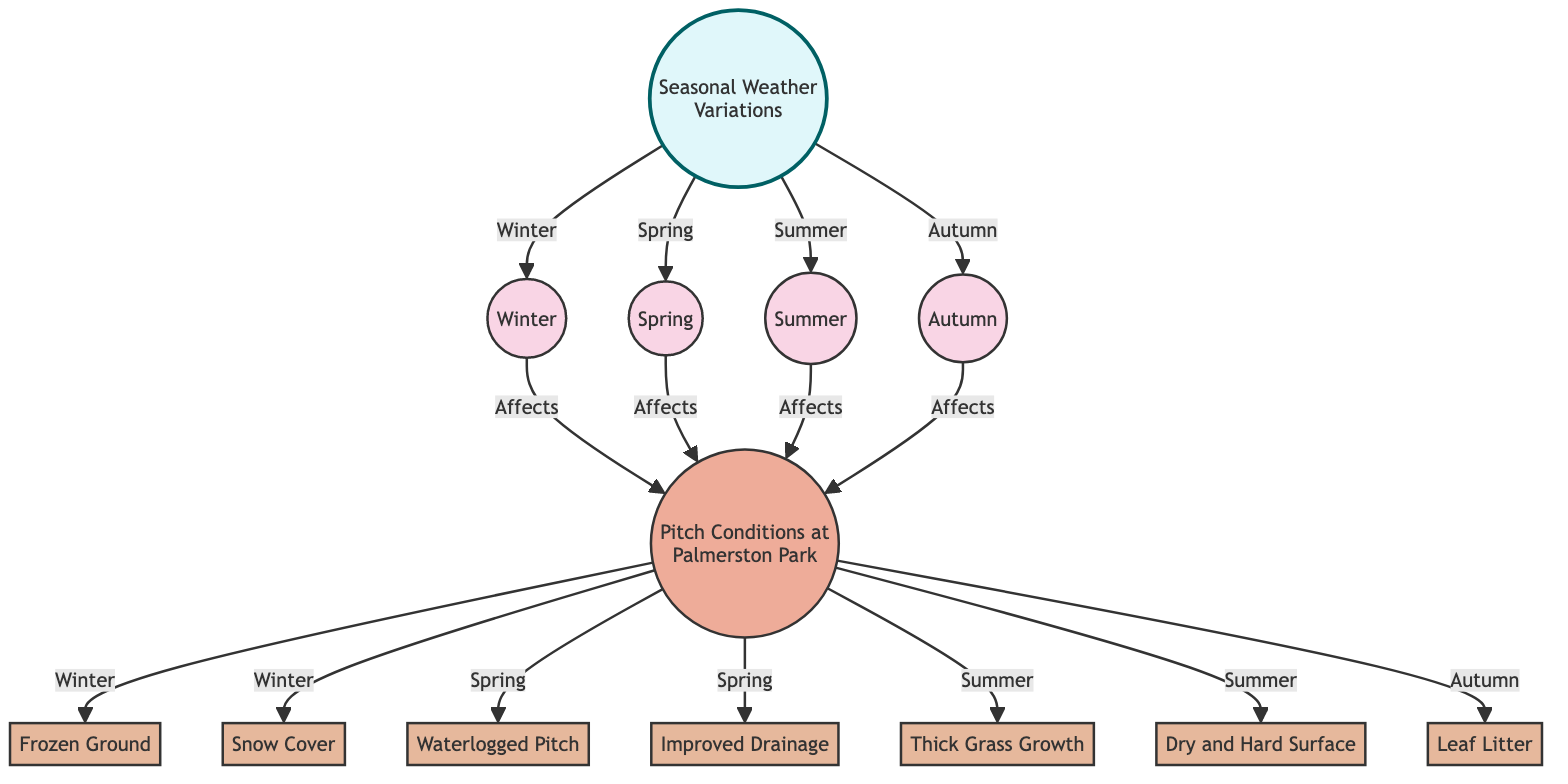What seasons affect the pitch conditions at Palmerston Park? The diagram indicates that all four seasons (Winter, Spring, Summer, and Autumn) affect the pitch conditions at Palmerston Park, as there are arrows from each season pointing to the pitch conditions node.
Answer: Winter, Spring, Summer, Autumn How many effects are listed for pitch conditions? There are a total of seven effects listed under the pitch conditions node (Frozen Ground, Snow Cover, Waterlogged Pitch, Improved Drainage, Thick Grass Growth, Dry and Hard Surface, Leaf Litter), which can be counted directly on the diagram.
Answer: 7 Which season is associated with Frozen Ground? According to the diagram, Frozen Ground is specifically connected to the Winter season, indicated by the arrow pointing from Winter to the Frozen Ground effect node.
Answer: Winter What are the effects of Spring on pitch conditions? The diagram shows that Spring impacts two effects, which are Waterlogged Pitch and Improved Drainage, as there are arrows leading from Spring to these two nodes.
Answer: Waterlogged Pitch, Improved Drainage Which effect is linked to Summer and what is its condition? The diagram indicates that Summer is connected to two effects: Thick Grass Growth and Dry and Hard Surface, represented by arrows leading from Summer to both effect nodes.
Answer: Thick Grass Growth, Dry and Hard Surface What effect is associated with Autumn and what is its condition? The diagram shows that the effect associated with Autumn is Leaf Litter, as there is an arrow leading from Autumn to the Leaf Litter effect node.
Answer: Leaf Litter How does Winter uniquely affect pitch conditions? Winter uniquely affects the pitch conditions by causing Frozen Ground and Snow Cover, as indicated by the arrows connecting Winter to these two specific effects.
Answer: Frozen Ground, Snow Cover Which season leads to Improved Drainage? The diagram states that Improved Drainage is influenced by Spring, as depicted by the arrow from Spring pointing to the Improved Drainage effect node.
Answer: Spring 